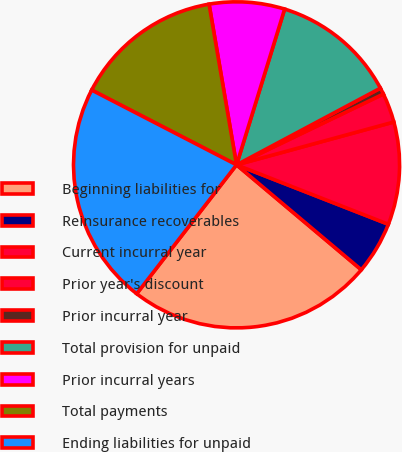<chart> <loc_0><loc_0><loc_500><loc_500><pie_chart><fcel>Beginning liabilities for<fcel>Reinsurance recoverables<fcel>Current incurral year<fcel>Prior year's discount<fcel>Prior incurral year<fcel>Total provision for unpaid<fcel>Prior incurral years<fcel>Total payments<fcel>Ending liabilities for unpaid<nl><fcel>24.36%<fcel>5.19%<fcel>10.17%<fcel>2.92%<fcel>0.64%<fcel>12.44%<fcel>7.46%<fcel>14.72%<fcel>22.09%<nl></chart> 